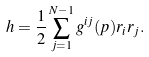<formula> <loc_0><loc_0><loc_500><loc_500>h = \frac { 1 } { 2 } \sum _ { j = 1 } ^ { N - 1 } g ^ { i j } ( p ) r _ { i } r _ { j } .</formula> 